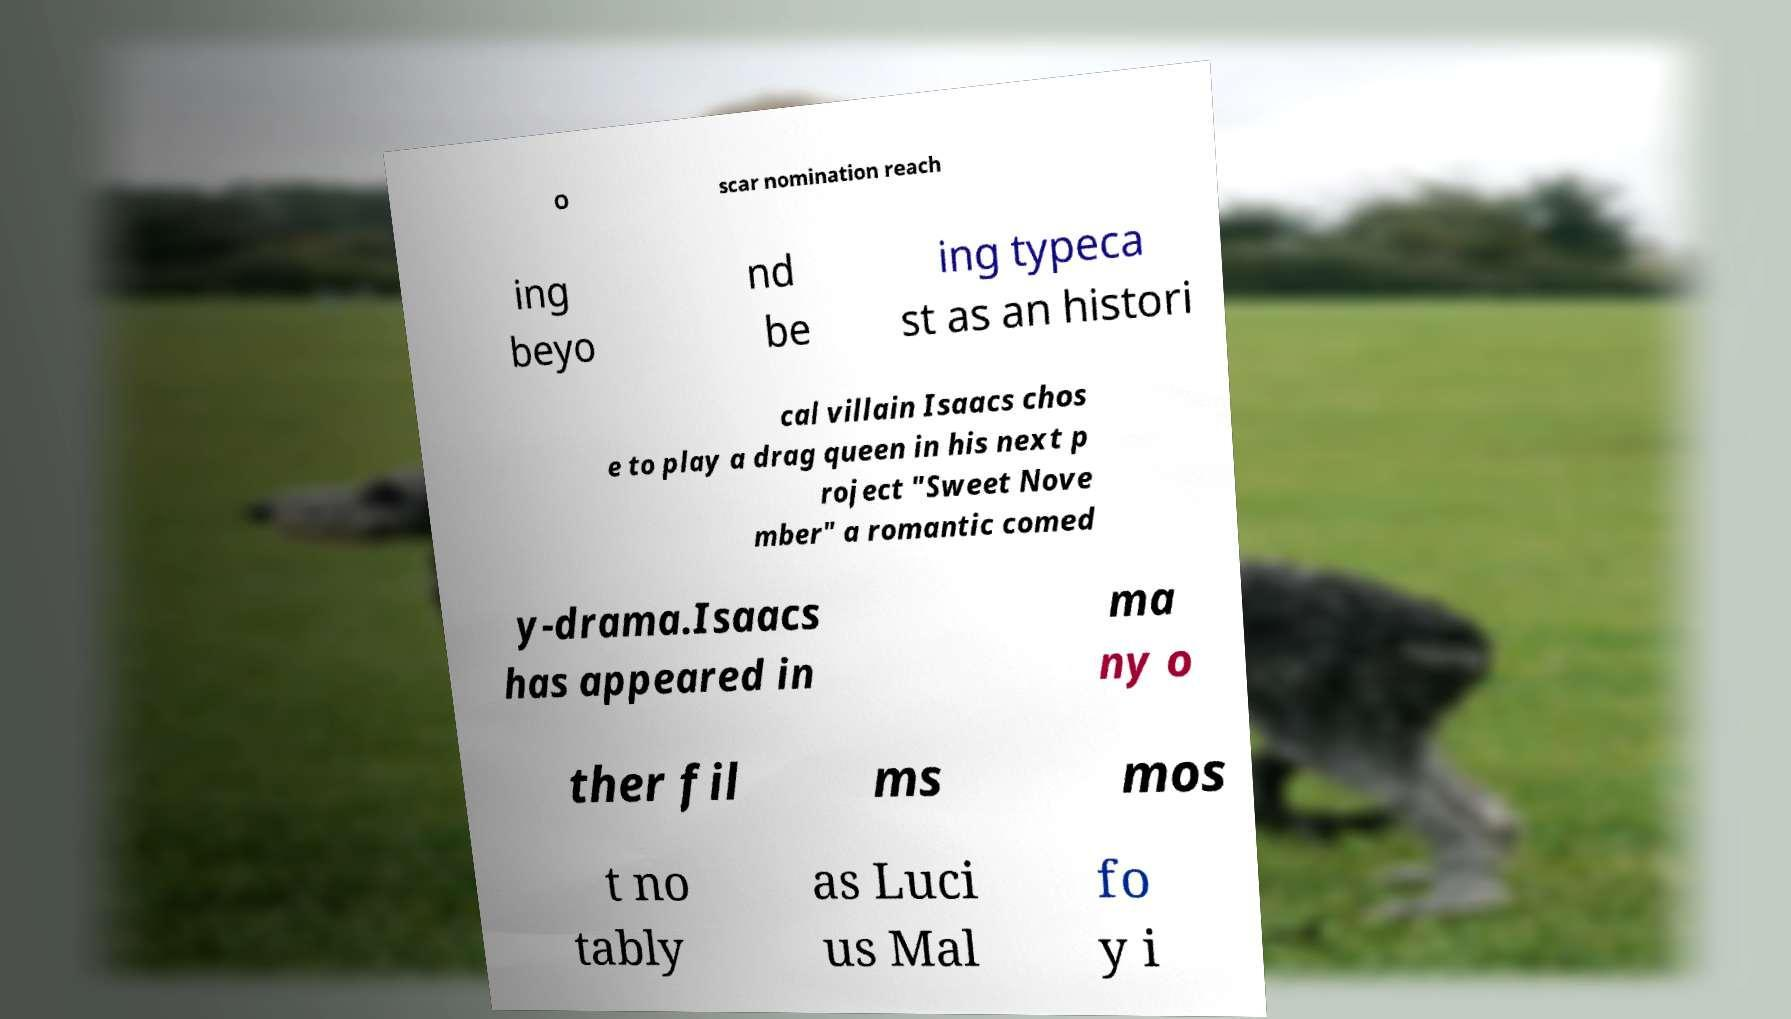Can you accurately transcribe the text from the provided image for me? O scar nomination reach ing beyo nd be ing typeca st as an histori cal villain Isaacs chos e to play a drag queen in his next p roject "Sweet Nove mber" a romantic comed y-drama.Isaacs has appeared in ma ny o ther fil ms mos t no tably as Luci us Mal fo y i 